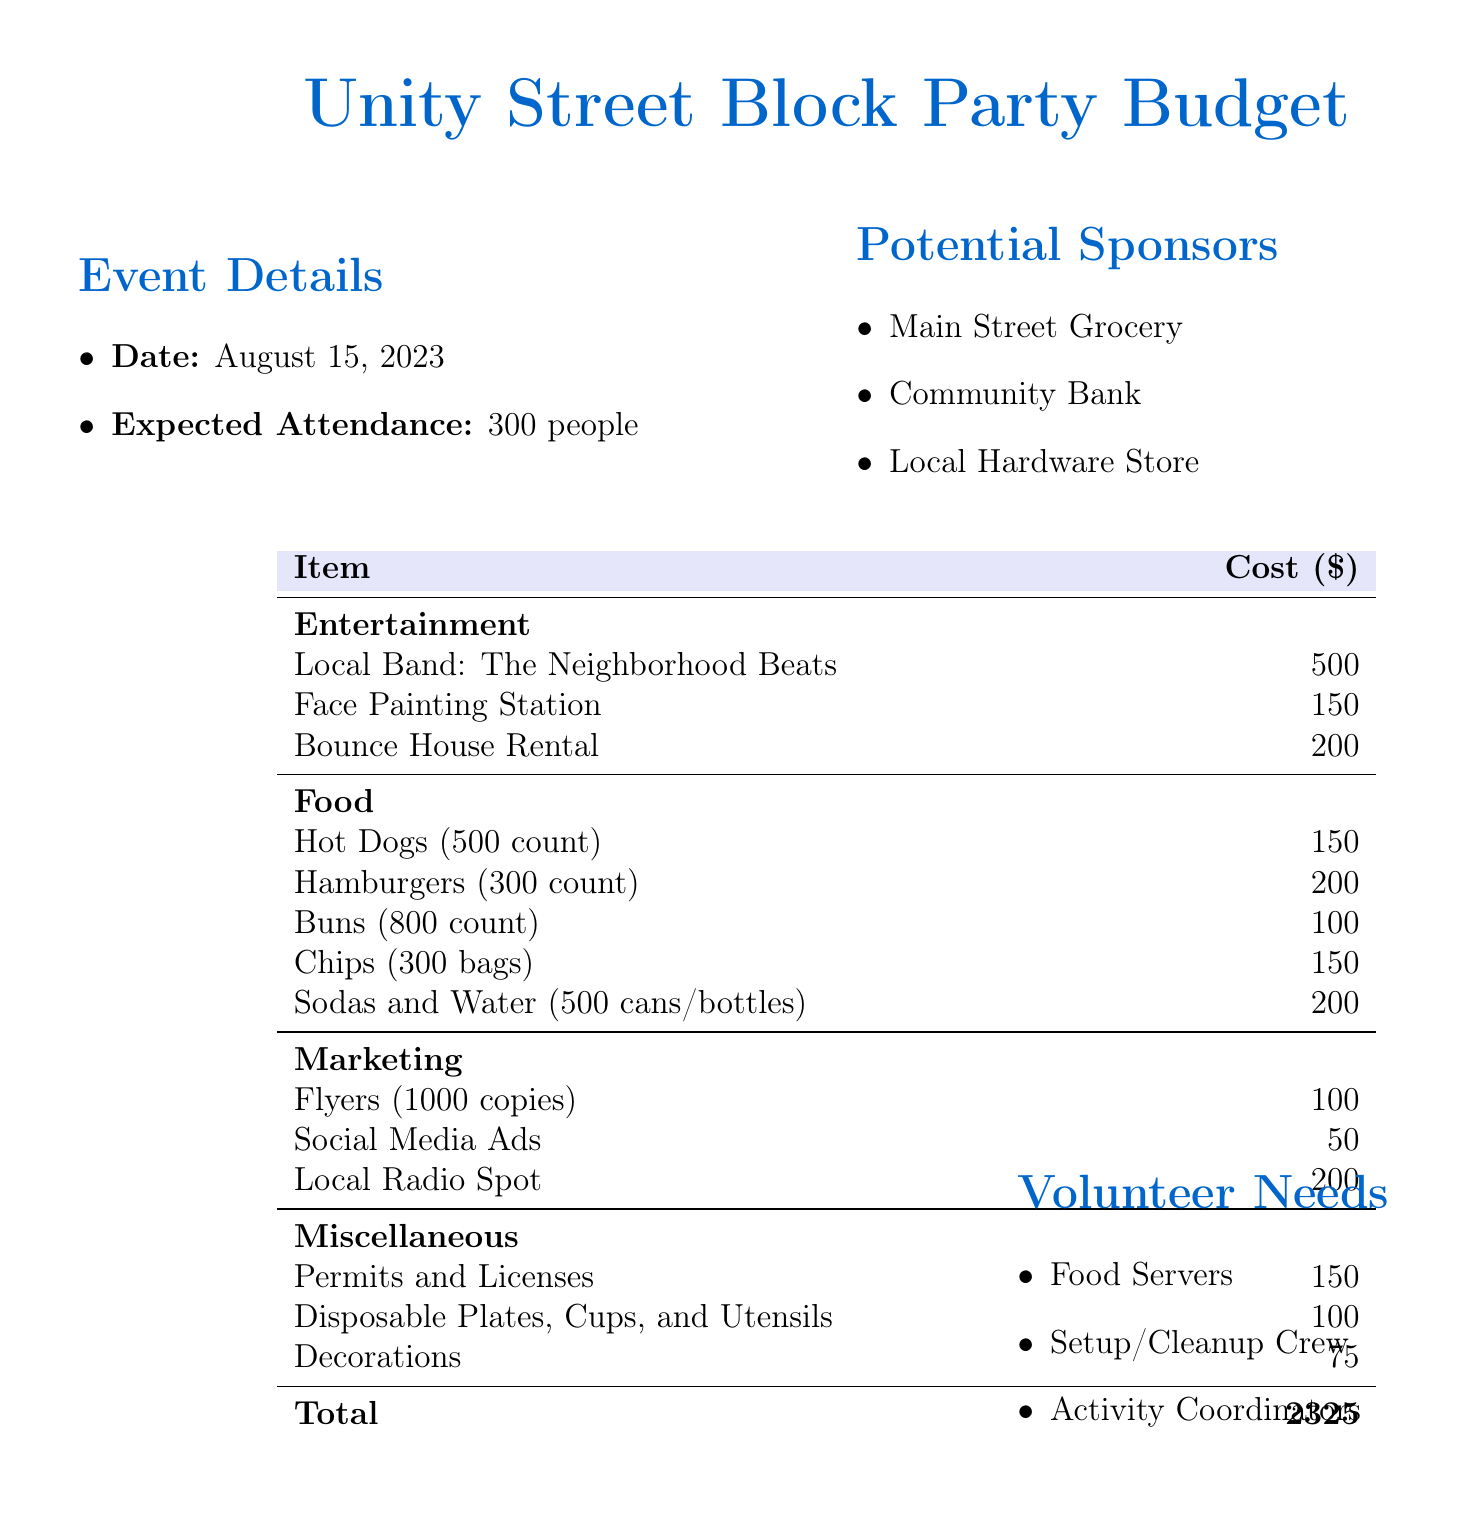What is the date of the event? The date of the event is specified in the document under Event Details.
Answer: August 15, 2023 What is the expected attendance? The expected attendance is mentioned in the document under Event Details.
Answer: 300 people How much does the local band cost? The cost for the local band is listed under the Entertainment section of the budget table.
Answer: 500 What is the total budget for the block party? The total budget is calculated as the sum of all cost items in the budget table.
Answer: 2325 What is the cost of the face painting station? The cost for the face painting station is found under the Entertainment section in the budget table.
Answer: 150 Which local business is a potential sponsor? The document lists potential sponsors; one of them is mentioned under Potential Sponsors.
Answer: Main Street Grocery How many hamburgers will be provided? The quantity of hamburgers can be found under the Food section in the budget table.
Answer: 300 What miscellaneous item costs 100? The cost of 100 for a miscellaneous item can be located under the Miscellaneous section of the budget table.
Answer: Disposable Plates, Cups, and Utensils 